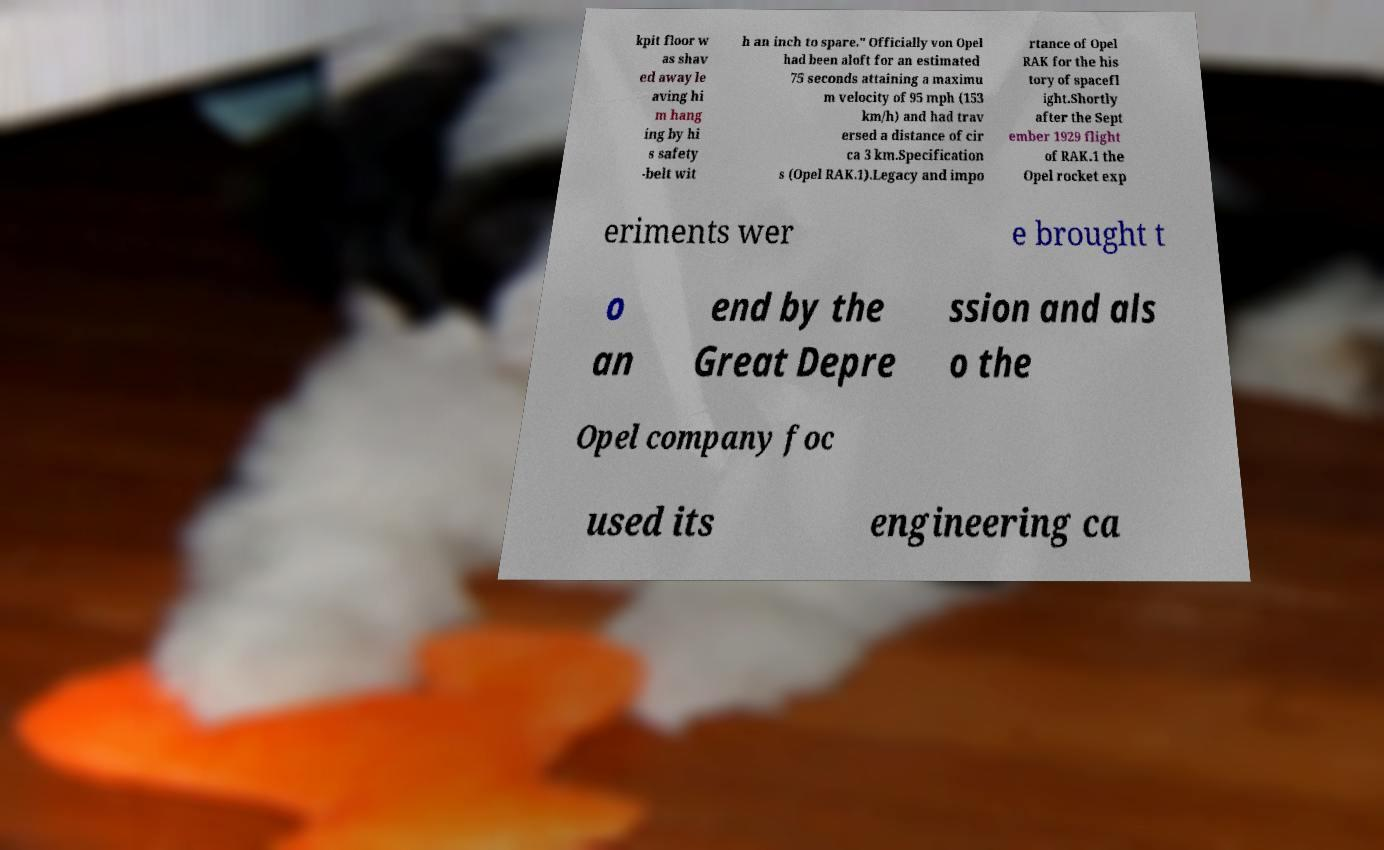Can you accurately transcribe the text from the provided image for me? kpit floor w as shav ed away le aving hi m hang ing by hi s safety -belt wit h an inch to spare." Officially von Opel had been aloft for an estimated 75 seconds attaining a maximu m velocity of 95 mph (153 km/h) and had trav ersed a distance of cir ca 3 km.Specification s (Opel RAK.1).Legacy and impo rtance of Opel RAK for the his tory of spacefl ight.Shortly after the Sept ember 1929 flight of RAK.1 the Opel rocket exp eriments wer e brought t o an end by the Great Depre ssion and als o the Opel company foc used its engineering ca 